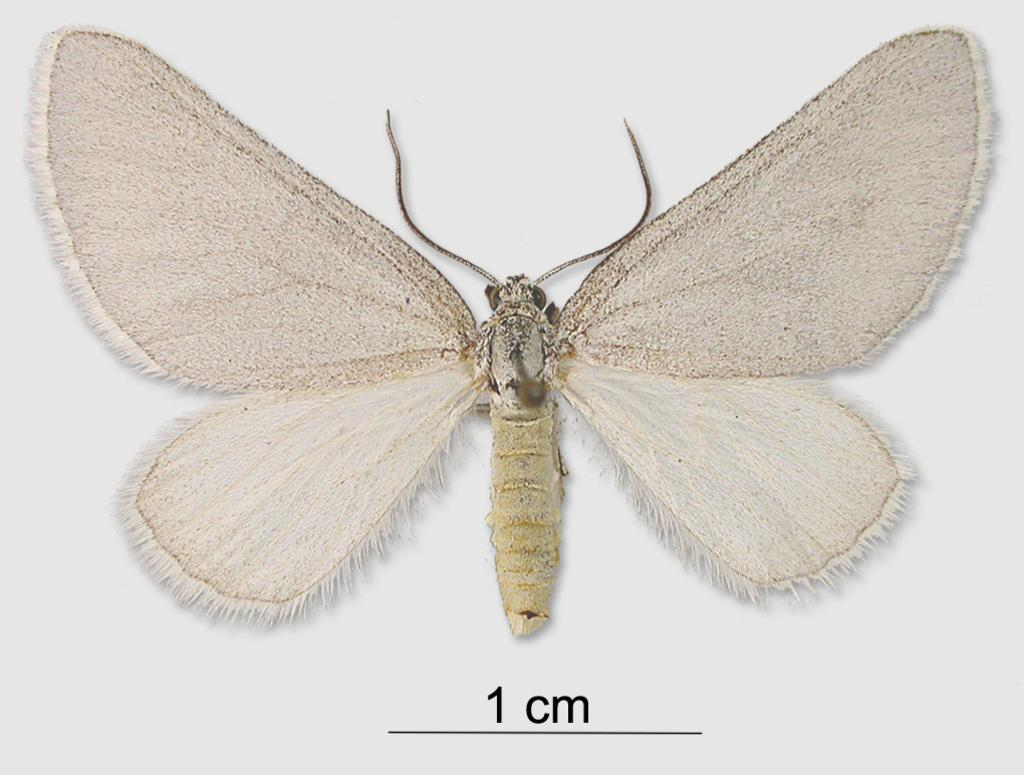What type of creature can be seen in the image? There is an insect in the image. Where is the insect located? The insect is on a white object. What else can be observed in the image besides the insect? There is writing on the image. How does the insect react to the zephyr in the image? There is no mention of a zephyr or any wind in the image, so it is not possible to determine how the insect might react. 